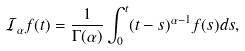<formula> <loc_0><loc_0><loc_500><loc_500>\mathcal { I } _ { \alpha } f ( t ) = \frac { 1 } { \Gamma ( \alpha ) } \int _ { 0 } ^ { t } ( t - s ) ^ { \alpha - 1 } f ( s ) d s ,</formula> 